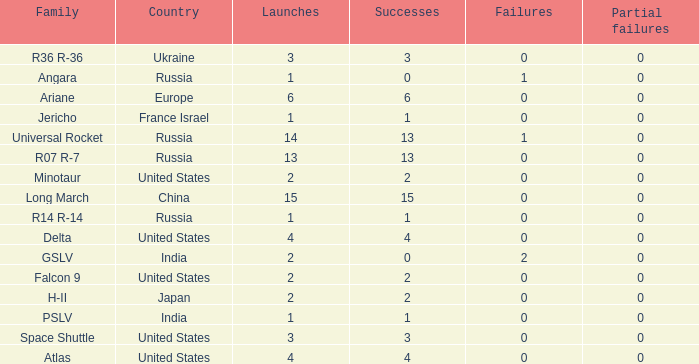What is the number of failure for the country of Russia, and a Family of r14 r-14, and a Partial failures smaller than 0? 0.0. 